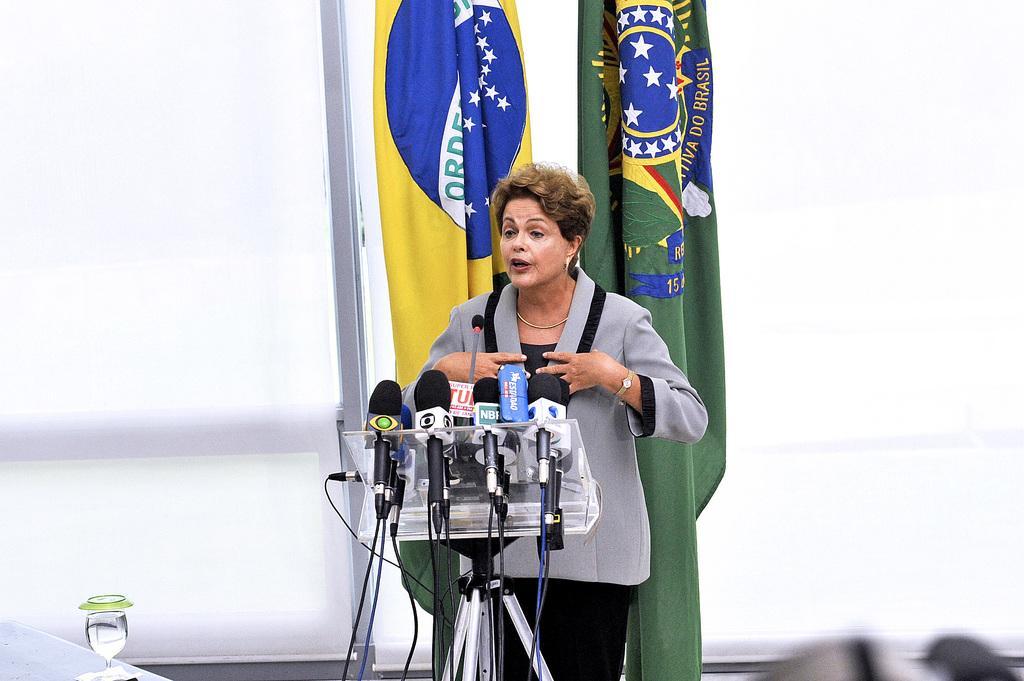In one or two sentences, can you explain what this image depicts? In this image I can see a woman is standing in front of microphones. In the background I can see flags. Here I can see a glass. 